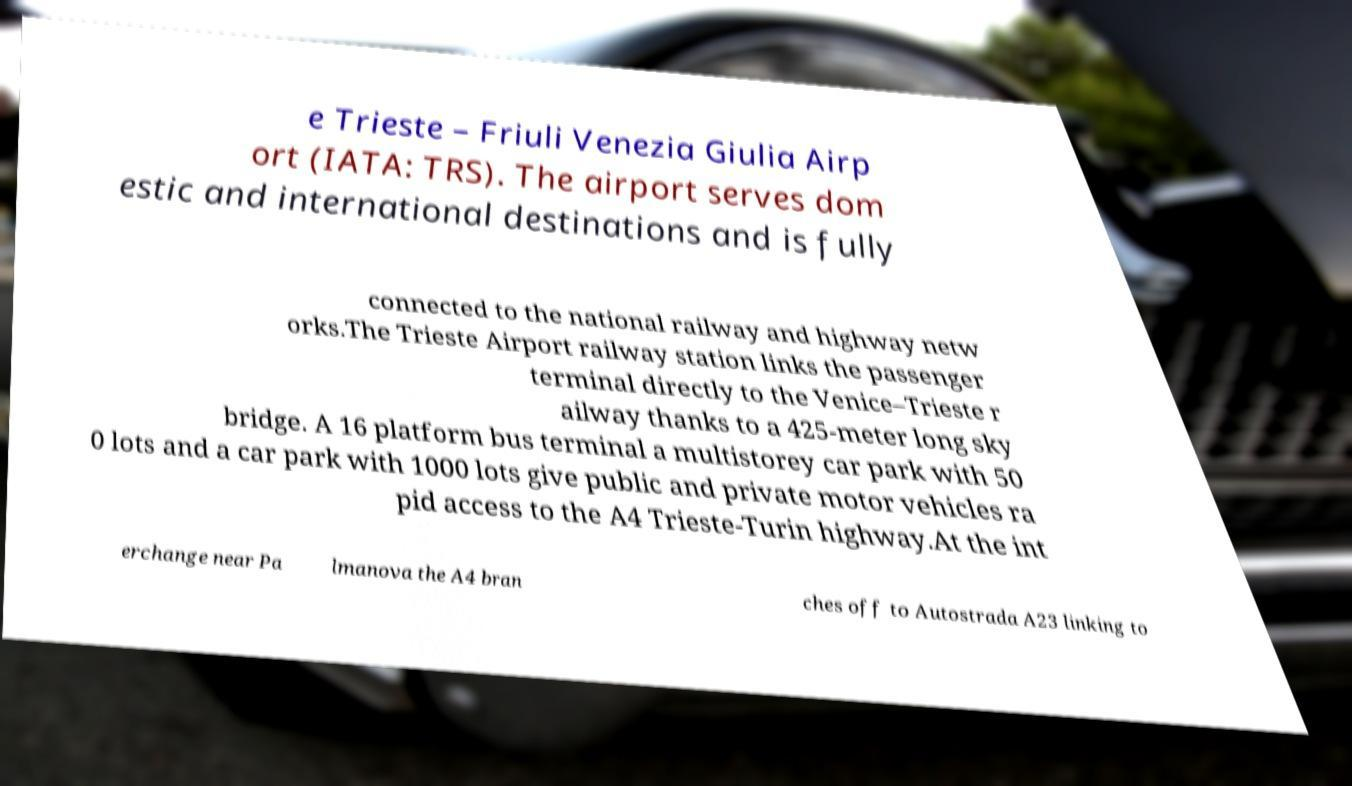Could you extract and type out the text from this image? e Trieste – Friuli Venezia Giulia Airp ort (IATA: TRS). The airport serves dom estic and international destinations and is fully connected to the national railway and highway netw orks.The Trieste Airport railway station links the passenger terminal directly to the Venice–Trieste r ailway thanks to a 425-meter long sky bridge. A 16 platform bus terminal a multistorey car park with 50 0 lots and a car park with 1000 lots give public and private motor vehicles ra pid access to the A4 Trieste-Turin highway.At the int erchange near Pa lmanova the A4 bran ches off to Autostrada A23 linking to 